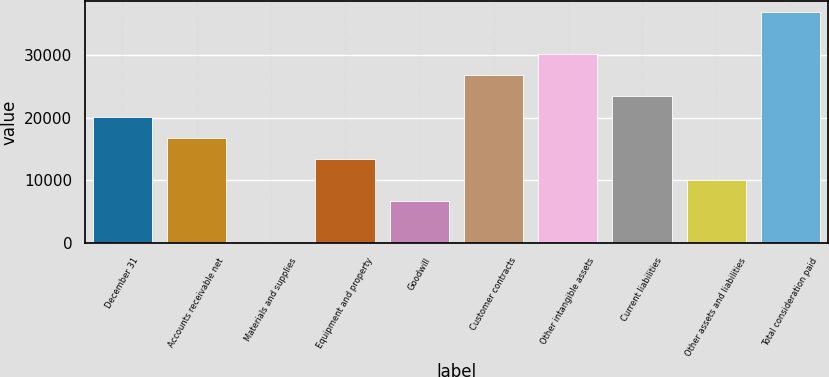Convert chart. <chart><loc_0><loc_0><loc_500><loc_500><bar_chart><fcel>December 31<fcel>Accounts receivable net<fcel>Materials and supplies<fcel>Equipment and property<fcel>Goodwill<fcel>Customer contracts<fcel>Other intangible assets<fcel>Current liabilities<fcel>Other assets and liabilities<fcel>Total consideration paid<nl><fcel>20156.6<fcel>16809<fcel>71<fcel>13461.4<fcel>6766.2<fcel>26851.8<fcel>30199.4<fcel>23504.2<fcel>10113.8<fcel>36894.6<nl></chart> 